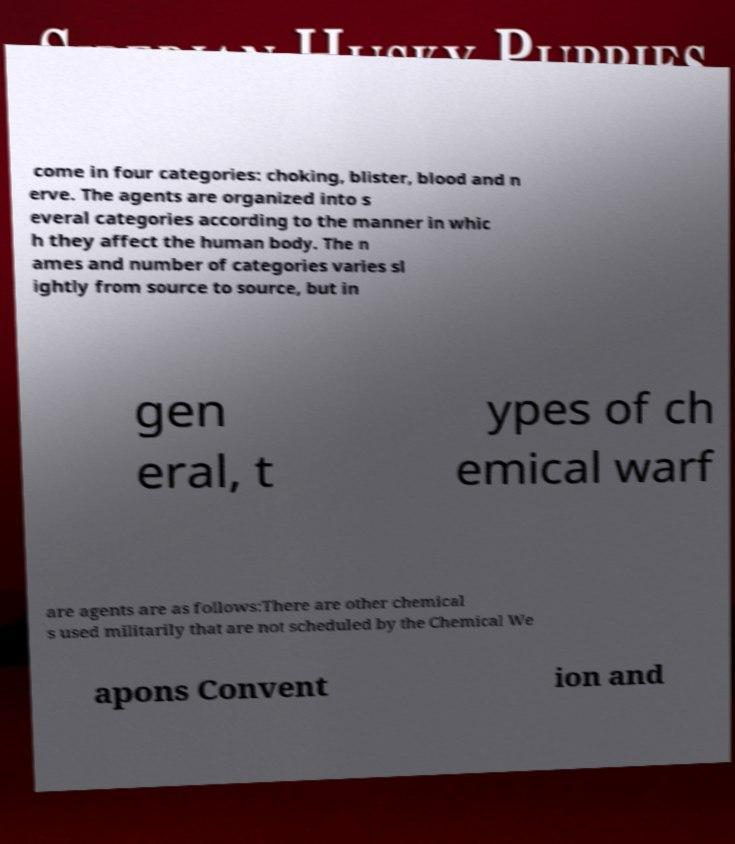Please read and relay the text visible in this image. What does it say? come in four categories: choking, blister, blood and n erve. The agents are organized into s everal categories according to the manner in whic h they affect the human body. The n ames and number of categories varies sl ightly from source to source, but in gen eral, t ypes of ch emical warf are agents are as follows:There are other chemical s used militarily that are not scheduled by the Chemical We apons Convent ion and 